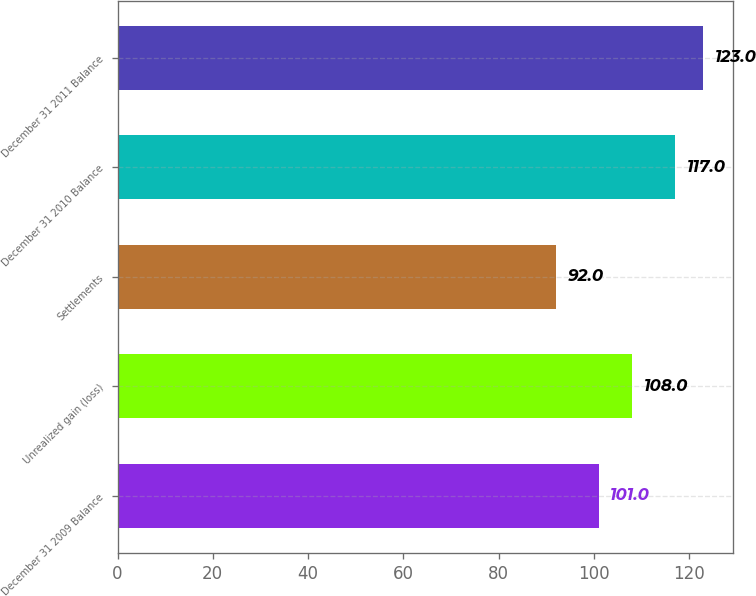Convert chart to OTSL. <chart><loc_0><loc_0><loc_500><loc_500><bar_chart><fcel>December 31 2009 Balance<fcel>Unrealized gain (loss)<fcel>Settlements<fcel>December 31 2010 Balance<fcel>December 31 2011 Balance<nl><fcel>101<fcel>108<fcel>92<fcel>117<fcel>123<nl></chart> 